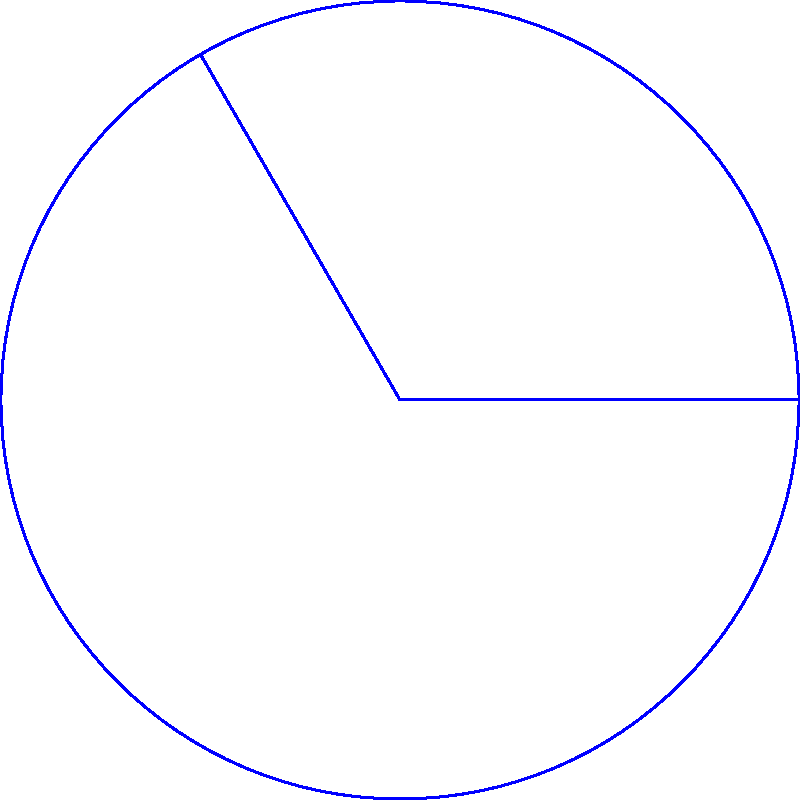As an executive director overseeing IT projects, you're planning the installation of a new Wi-Fi router in an open office space. The router has a range of 15 meters and provides coverage in a 120° angle. What is the approximate coverage area of this Wi-Fi router in square meters? To solve this problem, we need to calculate the area of a circular sector. Here's a step-by-step approach:

1) The formula for the area of a circular sector is:
   $$A = \frac{1}{2} r^2 \theta$$
   Where $r$ is the radius and $\theta$ is the angle in radians.

2) We're given:
   - Radius (r) = 15 meters
   - Angle = 120°

3) Convert the angle from degrees to radians:
   $$\theta = 120° \times \frac{\pi}{180°} = \frac{2\pi}{3} \approx 2.0944 \text{ radians}$$

4) Now, let's substitute these values into our formula:
   $$A = \frac{1}{2} \times 15^2 \times \frac{2\pi}{3}$$

5) Simplify:
   $$A = \frac{1}{2} \times 225 \times \frac{2\pi}{3} = 75\pi \approx 235.62 \text{ m}^2$$

Therefore, the approximate coverage area of the Wi-Fi router is about 236 square meters.
Answer: 236 m² 